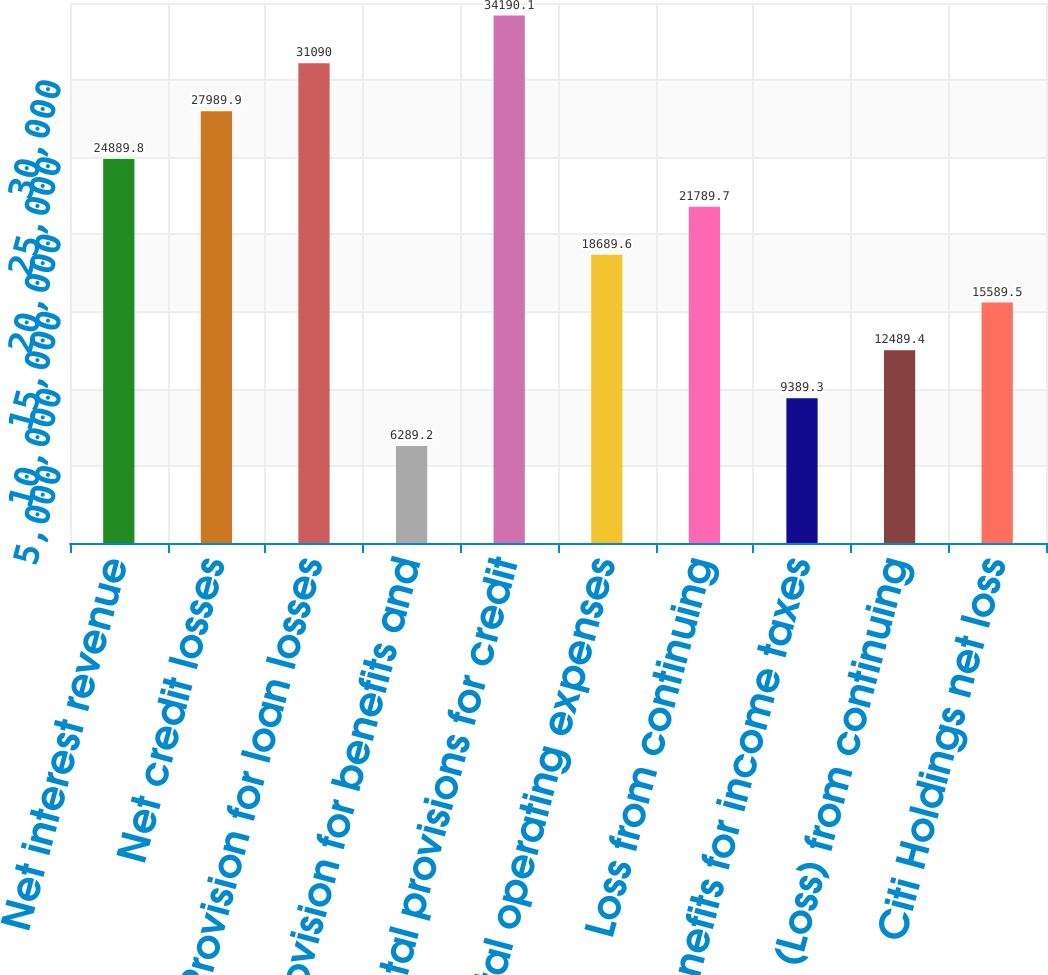Convert chart to OTSL. <chart><loc_0><loc_0><loc_500><loc_500><bar_chart><fcel>Net interest revenue<fcel>Net credit losses<fcel>Provision for loan losses<fcel>Provision for benefits and<fcel>Total provisions for credit<fcel>Total operating expenses<fcel>Loss from continuing<fcel>Benefits for income taxes<fcel>(Loss) from continuing<fcel>Citi Holdings net loss<nl><fcel>24889.8<fcel>27989.9<fcel>31090<fcel>6289.2<fcel>34190.1<fcel>18689.6<fcel>21789.7<fcel>9389.3<fcel>12489.4<fcel>15589.5<nl></chart> 